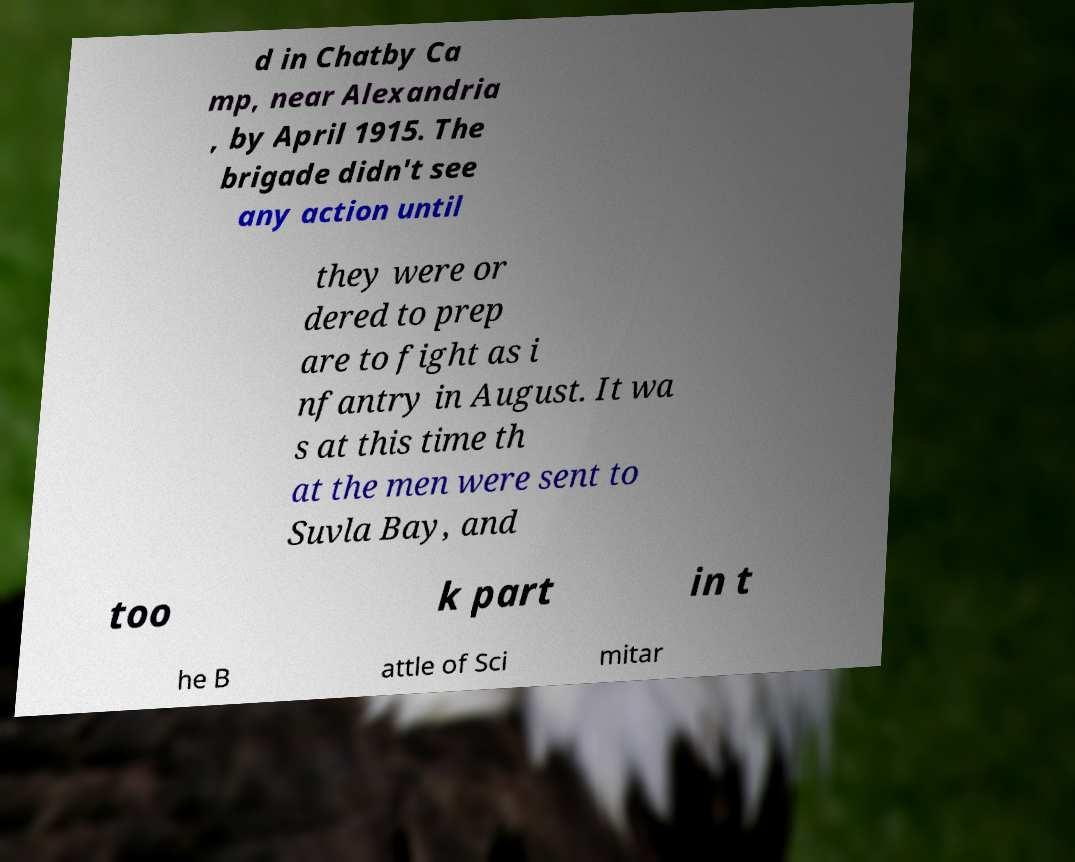What messages or text are displayed in this image? I need them in a readable, typed format. d in Chatby Ca mp, near Alexandria , by April 1915. The brigade didn't see any action until they were or dered to prep are to fight as i nfantry in August. It wa s at this time th at the men were sent to Suvla Bay, and too k part in t he B attle of Sci mitar 